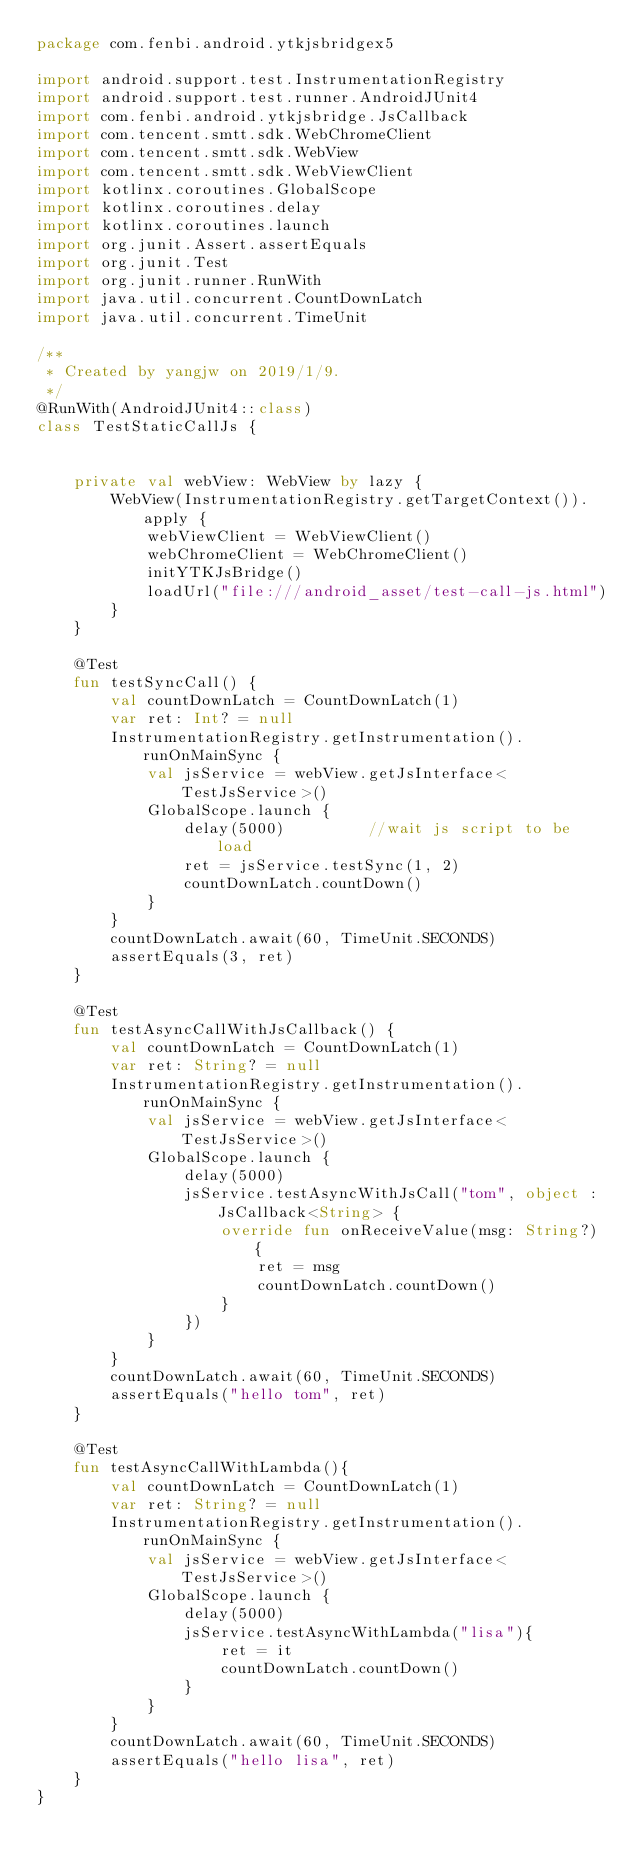Convert code to text. <code><loc_0><loc_0><loc_500><loc_500><_Kotlin_>package com.fenbi.android.ytkjsbridgex5

import android.support.test.InstrumentationRegistry
import android.support.test.runner.AndroidJUnit4
import com.fenbi.android.ytkjsbridge.JsCallback
import com.tencent.smtt.sdk.WebChromeClient
import com.tencent.smtt.sdk.WebView
import com.tencent.smtt.sdk.WebViewClient
import kotlinx.coroutines.GlobalScope
import kotlinx.coroutines.delay
import kotlinx.coroutines.launch
import org.junit.Assert.assertEquals
import org.junit.Test
import org.junit.runner.RunWith
import java.util.concurrent.CountDownLatch
import java.util.concurrent.TimeUnit

/**
 * Created by yangjw on 2019/1/9.
 */
@RunWith(AndroidJUnit4::class)
class TestStaticCallJs {


    private val webView: WebView by lazy {
        WebView(InstrumentationRegistry.getTargetContext()).apply {
            webViewClient = WebViewClient()
            webChromeClient = WebChromeClient()
            initYTKJsBridge()
            loadUrl("file:///android_asset/test-call-js.html")
        }
    }

    @Test
    fun testSyncCall() {
        val countDownLatch = CountDownLatch(1)
        var ret: Int? = null
        InstrumentationRegistry.getInstrumentation().runOnMainSync {
            val jsService = webView.getJsInterface<TestJsService>()
            GlobalScope.launch {
                delay(5000)         //wait js script to be load
                ret = jsService.testSync(1, 2)
                countDownLatch.countDown()
            }
        }
        countDownLatch.await(60, TimeUnit.SECONDS)
        assertEquals(3, ret)
    }

    @Test
    fun testAsyncCallWithJsCallback() {
        val countDownLatch = CountDownLatch(1)
        var ret: String? = null
        InstrumentationRegistry.getInstrumentation().runOnMainSync {
            val jsService = webView.getJsInterface<TestJsService>()
            GlobalScope.launch {
                delay(5000)
                jsService.testAsyncWithJsCall("tom", object : JsCallback<String> {
                    override fun onReceiveValue(msg: String?) {
                        ret = msg
                        countDownLatch.countDown()
                    }
                })
            }
        }
        countDownLatch.await(60, TimeUnit.SECONDS)
        assertEquals("hello tom", ret)
    }

    @Test
    fun testAsyncCallWithLambda(){
        val countDownLatch = CountDownLatch(1)
        var ret: String? = null
        InstrumentationRegistry.getInstrumentation().runOnMainSync {
            val jsService = webView.getJsInterface<TestJsService>()
            GlobalScope.launch {
                delay(5000)
                jsService.testAsyncWithLambda("lisa"){
                    ret = it
                    countDownLatch.countDown()
                }
            }
        }
        countDownLatch.await(60, TimeUnit.SECONDS)
        assertEquals("hello lisa", ret)
    }
}</code> 